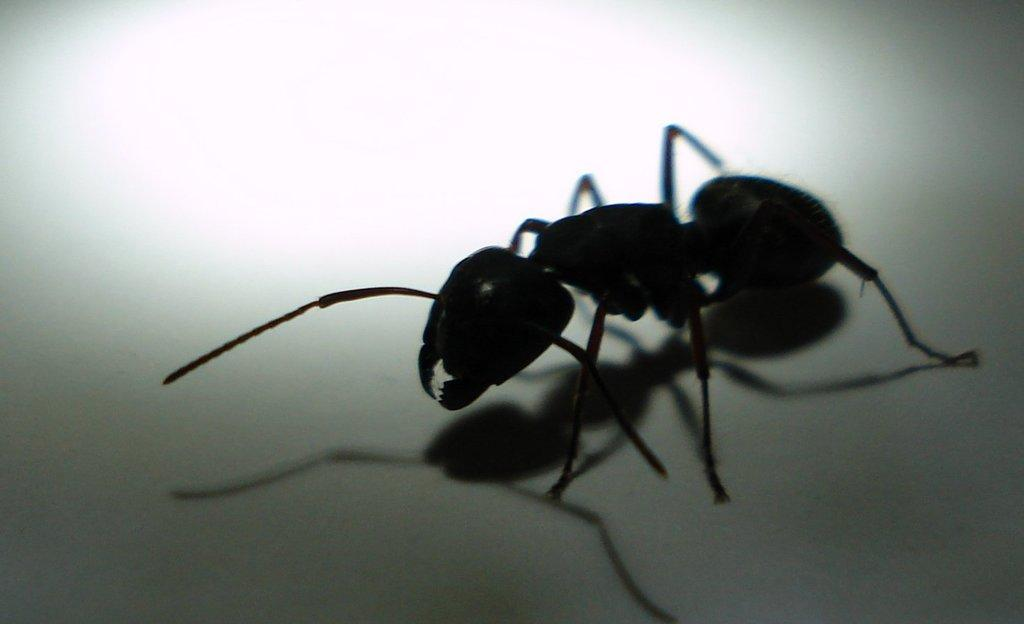What type of insect is present in the image? There is an ant in the image. What is the color of the ant? The ant is black in color. What is the color of the surface the ant is on? The ant is on a white colored surface. What class does the ant teach in the image? There is no indication in the image that the ant is teaching a class, as ants do not teach classes. 